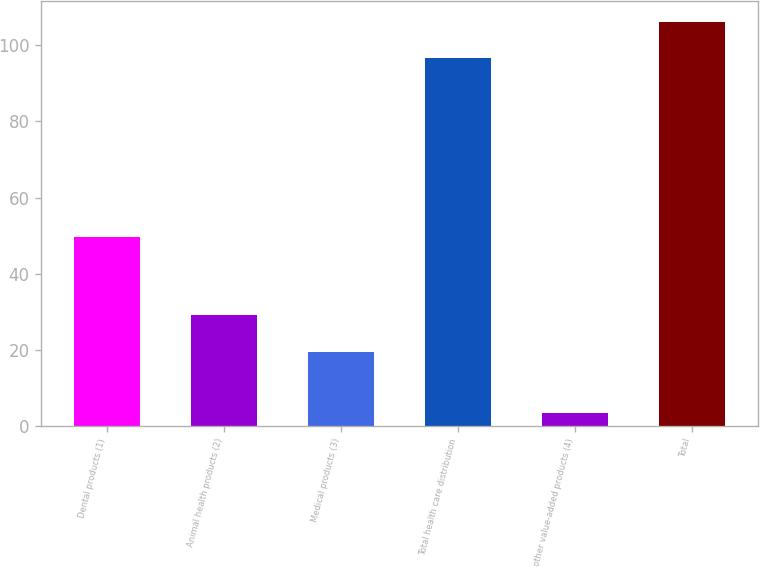Convert chart. <chart><loc_0><loc_0><loc_500><loc_500><bar_chart><fcel>Dental products (1)<fcel>Animal health products (2)<fcel>Medical products (3)<fcel>Total health care distribution<fcel>other value-added products (4)<fcel>Total<nl><fcel>49.6<fcel>29.16<fcel>19.5<fcel>96.6<fcel>3.4<fcel>106.26<nl></chart> 